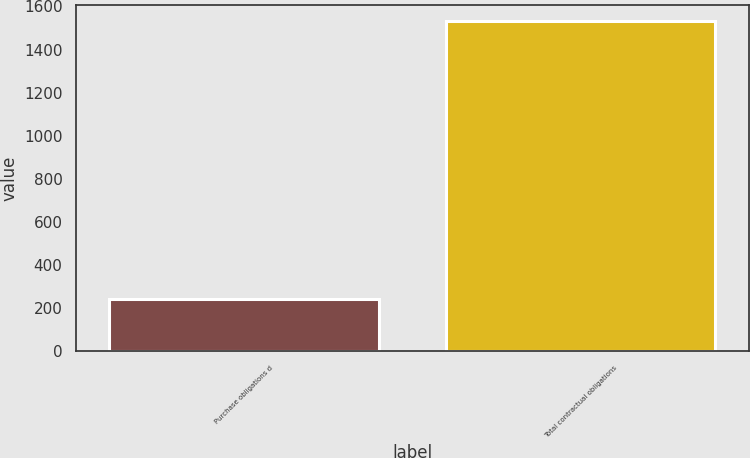Convert chart. <chart><loc_0><loc_0><loc_500><loc_500><bar_chart><fcel>Purchase obligations d<fcel>Total contractual obligations<nl><fcel>245<fcel>1532<nl></chart> 